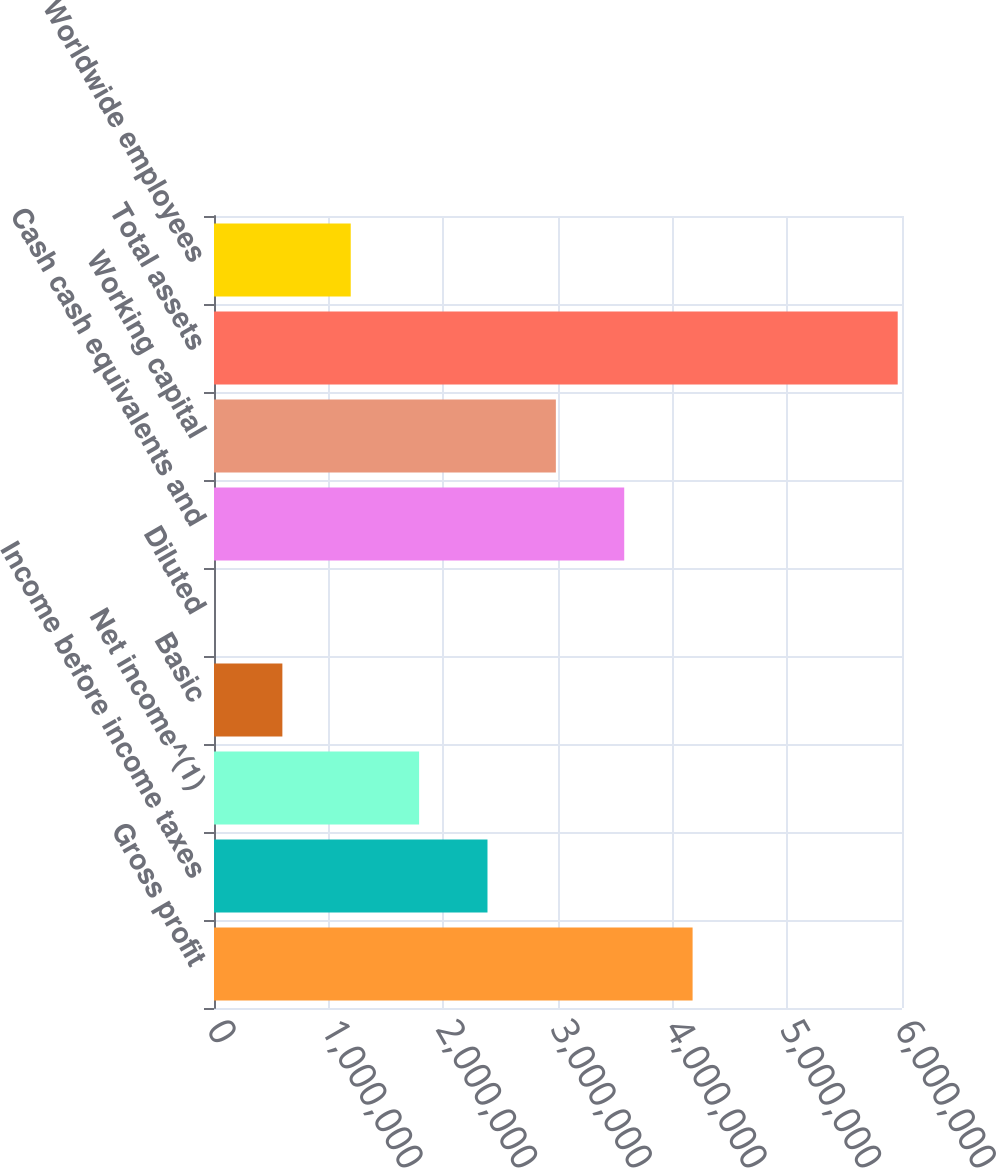<chart> <loc_0><loc_0><loc_500><loc_500><bar_chart><fcel>Gross profit<fcel>Income before income taxes<fcel>Net income^(1)<fcel>Basic<fcel>Diluted<fcel>Cash cash equivalents and<fcel>Working capital<fcel>Total assets<fcel>Worldwide employees<nl><fcel>4.17378e+06<fcel>2.38502e+06<fcel>1.78876e+06<fcel>596256<fcel>0.83<fcel>3.57753e+06<fcel>2.98127e+06<fcel>5.96255e+06<fcel>1.19251e+06<nl></chart> 